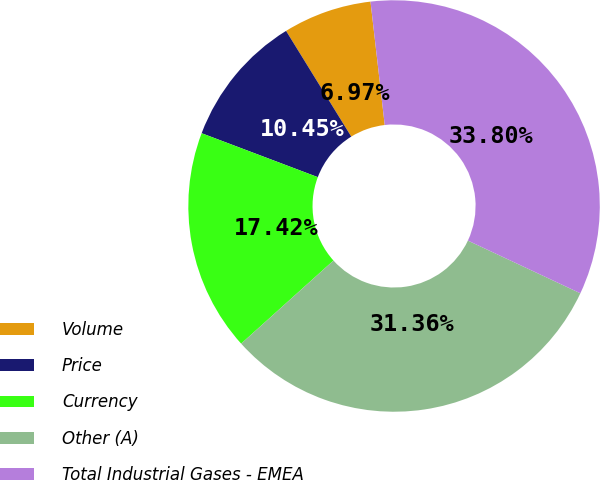Convert chart to OTSL. <chart><loc_0><loc_0><loc_500><loc_500><pie_chart><fcel>Volume<fcel>Price<fcel>Currency<fcel>Other (A)<fcel>Total Industrial Gases - EMEA<nl><fcel>6.97%<fcel>10.45%<fcel>17.42%<fcel>31.36%<fcel>33.8%<nl></chart> 